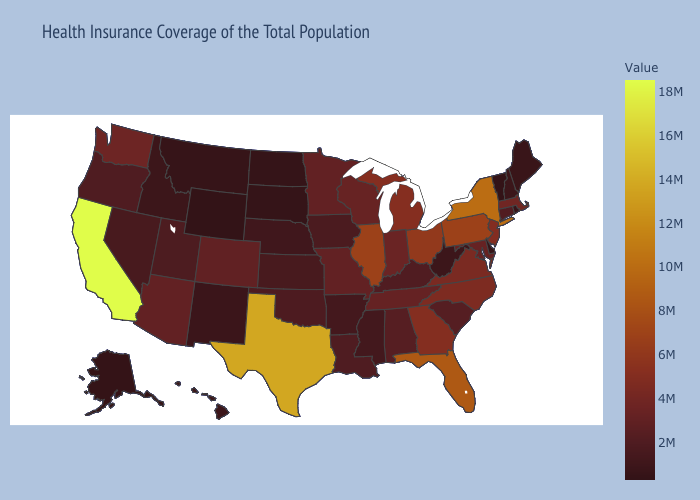Does Iowa have a higher value than New Jersey?
Write a very short answer. No. Among the states that border Massachusetts , does New Hampshire have the lowest value?
Be succinct. No. Is the legend a continuous bar?
Keep it brief. Yes. Among the states that border Massachusetts , does Vermont have the highest value?
Answer briefly. No. 